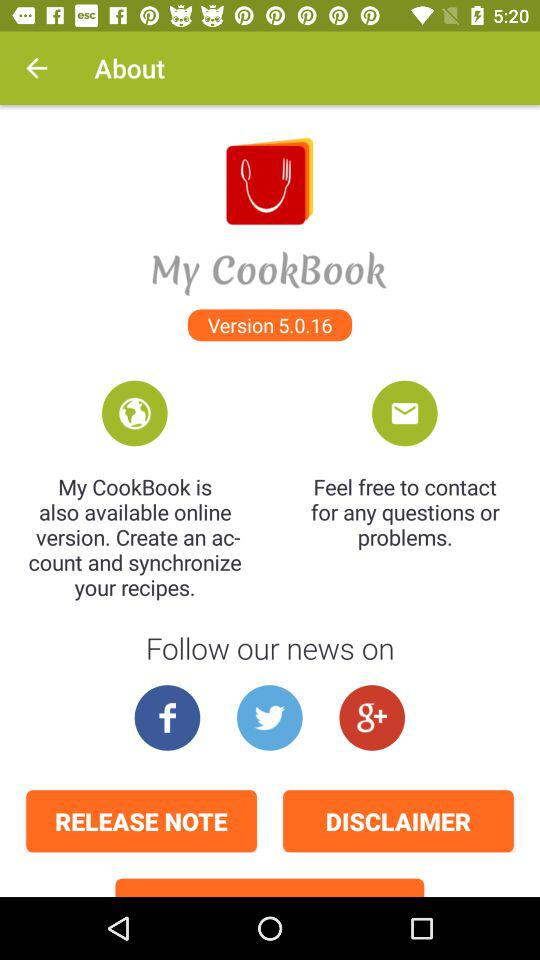On which applications can we follow the news? The applications are "Facebook", "Twitter" and "Google+". 